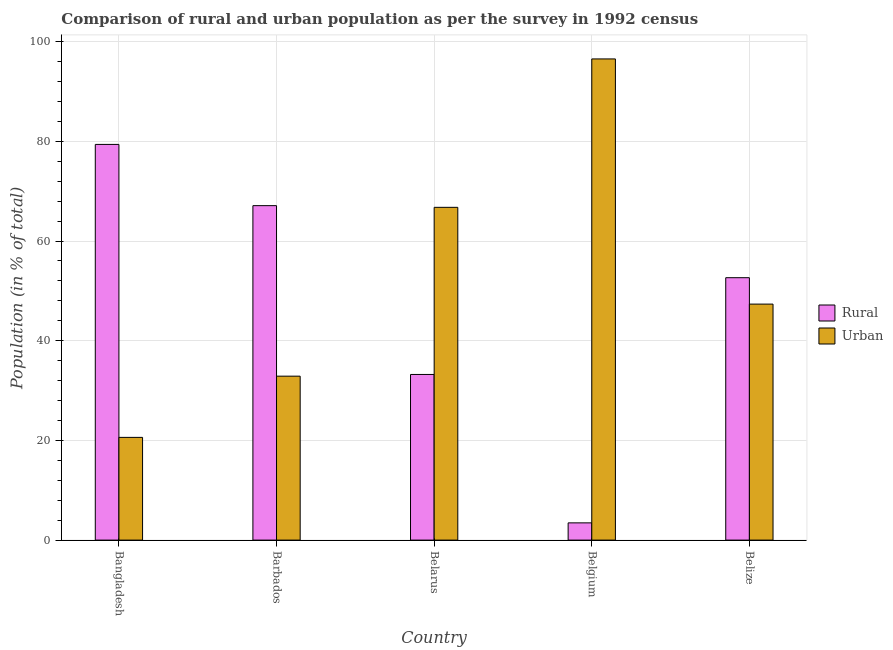How many different coloured bars are there?
Provide a succinct answer. 2. How many groups of bars are there?
Provide a short and direct response. 5. Are the number of bars per tick equal to the number of legend labels?
Give a very brief answer. Yes. Are the number of bars on each tick of the X-axis equal?
Give a very brief answer. Yes. What is the label of the 3rd group of bars from the left?
Keep it short and to the point. Belarus. What is the urban population in Belarus?
Offer a terse response. 66.77. Across all countries, what is the maximum urban population?
Provide a short and direct response. 96.54. Across all countries, what is the minimum rural population?
Provide a succinct answer. 3.46. In which country was the urban population maximum?
Keep it short and to the point. Belgium. What is the total urban population in the graph?
Make the answer very short. 264.16. What is the difference between the rural population in Barbados and that in Belarus?
Offer a terse response. 33.87. What is the difference between the rural population in Bangladesh and the urban population in Belarus?
Provide a succinct answer. 12.62. What is the average rural population per country?
Provide a short and direct response. 47.17. What is the difference between the rural population and urban population in Belgium?
Your response must be concise. -93.08. In how many countries, is the rural population greater than 88 %?
Your answer should be compact. 0. What is the ratio of the urban population in Barbados to that in Belgium?
Your answer should be compact. 0.34. Is the urban population in Bangladesh less than that in Barbados?
Ensure brevity in your answer.  Yes. What is the difference between the highest and the second highest rural population?
Ensure brevity in your answer.  12.28. What is the difference between the highest and the lowest rural population?
Keep it short and to the point. 75.93. Is the sum of the urban population in Bangladesh and Belize greater than the maximum rural population across all countries?
Provide a succinct answer. No. What does the 2nd bar from the left in Belgium represents?
Provide a short and direct response. Urban. What does the 1st bar from the right in Belgium represents?
Your response must be concise. Urban. What is the difference between two consecutive major ticks on the Y-axis?
Your answer should be compact. 20. Are the values on the major ticks of Y-axis written in scientific E-notation?
Your answer should be very brief. No. Does the graph contain any zero values?
Ensure brevity in your answer.  No. Where does the legend appear in the graph?
Make the answer very short. Center right. What is the title of the graph?
Give a very brief answer. Comparison of rural and urban population as per the survey in 1992 census. What is the label or title of the X-axis?
Ensure brevity in your answer.  Country. What is the label or title of the Y-axis?
Keep it short and to the point. Population (in % of total). What is the Population (in % of total) in Rural in Bangladesh?
Your response must be concise. 79.39. What is the Population (in % of total) of Urban in Bangladesh?
Your answer should be very brief. 20.61. What is the Population (in % of total) of Rural in Barbados?
Ensure brevity in your answer.  67.11. What is the Population (in % of total) in Urban in Barbados?
Your response must be concise. 32.89. What is the Population (in % of total) of Rural in Belarus?
Provide a short and direct response. 33.23. What is the Population (in % of total) in Urban in Belarus?
Give a very brief answer. 66.77. What is the Population (in % of total) in Rural in Belgium?
Give a very brief answer. 3.46. What is the Population (in % of total) in Urban in Belgium?
Your answer should be very brief. 96.54. What is the Population (in % of total) of Rural in Belize?
Your response must be concise. 52.65. What is the Population (in % of total) in Urban in Belize?
Offer a very short reply. 47.35. Across all countries, what is the maximum Population (in % of total) of Rural?
Make the answer very short. 79.39. Across all countries, what is the maximum Population (in % of total) of Urban?
Ensure brevity in your answer.  96.54. Across all countries, what is the minimum Population (in % of total) of Rural?
Your answer should be very brief. 3.46. Across all countries, what is the minimum Population (in % of total) in Urban?
Provide a succinct answer. 20.61. What is the total Population (in % of total) in Rural in the graph?
Give a very brief answer. 235.84. What is the total Population (in % of total) of Urban in the graph?
Offer a terse response. 264.16. What is the difference between the Population (in % of total) in Rural in Bangladesh and that in Barbados?
Make the answer very short. 12.28. What is the difference between the Population (in % of total) in Urban in Bangladesh and that in Barbados?
Offer a terse response. -12.28. What is the difference between the Population (in % of total) in Rural in Bangladesh and that in Belarus?
Provide a succinct answer. 46.16. What is the difference between the Population (in % of total) in Urban in Bangladesh and that in Belarus?
Keep it short and to the point. -46.16. What is the difference between the Population (in % of total) in Rural in Bangladesh and that in Belgium?
Your answer should be compact. 75.93. What is the difference between the Population (in % of total) in Urban in Bangladesh and that in Belgium?
Your response must be concise. -75.93. What is the difference between the Population (in % of total) of Rural in Bangladesh and that in Belize?
Offer a terse response. 26.74. What is the difference between the Population (in % of total) of Urban in Bangladesh and that in Belize?
Keep it short and to the point. -26.74. What is the difference between the Population (in % of total) of Rural in Barbados and that in Belarus?
Your answer should be very brief. 33.87. What is the difference between the Population (in % of total) of Urban in Barbados and that in Belarus?
Provide a short and direct response. -33.87. What is the difference between the Population (in % of total) in Rural in Barbados and that in Belgium?
Ensure brevity in your answer.  63.65. What is the difference between the Population (in % of total) in Urban in Barbados and that in Belgium?
Your answer should be compact. -63.65. What is the difference between the Population (in % of total) in Rural in Barbados and that in Belize?
Your response must be concise. 14.46. What is the difference between the Population (in % of total) of Urban in Barbados and that in Belize?
Offer a terse response. -14.46. What is the difference between the Population (in % of total) of Rural in Belarus and that in Belgium?
Provide a succinct answer. 29.78. What is the difference between the Population (in % of total) of Urban in Belarus and that in Belgium?
Provide a succinct answer. -29.78. What is the difference between the Population (in % of total) in Rural in Belarus and that in Belize?
Provide a succinct answer. -19.41. What is the difference between the Population (in % of total) of Urban in Belarus and that in Belize?
Offer a very short reply. 19.41. What is the difference between the Population (in % of total) in Rural in Belgium and that in Belize?
Offer a very short reply. -49.19. What is the difference between the Population (in % of total) in Urban in Belgium and that in Belize?
Offer a terse response. 49.19. What is the difference between the Population (in % of total) in Rural in Bangladesh and the Population (in % of total) in Urban in Barbados?
Your answer should be very brief. 46.5. What is the difference between the Population (in % of total) in Rural in Bangladesh and the Population (in % of total) in Urban in Belarus?
Make the answer very short. 12.62. What is the difference between the Population (in % of total) in Rural in Bangladesh and the Population (in % of total) in Urban in Belgium?
Make the answer very short. -17.15. What is the difference between the Population (in % of total) in Rural in Bangladesh and the Population (in % of total) in Urban in Belize?
Keep it short and to the point. 32.04. What is the difference between the Population (in % of total) in Rural in Barbados and the Population (in % of total) in Urban in Belarus?
Offer a very short reply. 0.34. What is the difference between the Population (in % of total) of Rural in Barbados and the Population (in % of total) of Urban in Belgium?
Offer a terse response. -29.44. What is the difference between the Population (in % of total) of Rural in Barbados and the Population (in % of total) of Urban in Belize?
Offer a terse response. 19.75. What is the difference between the Population (in % of total) in Rural in Belarus and the Population (in % of total) in Urban in Belgium?
Your response must be concise. -63.31. What is the difference between the Population (in % of total) in Rural in Belarus and the Population (in % of total) in Urban in Belize?
Provide a short and direct response. -14.12. What is the difference between the Population (in % of total) of Rural in Belgium and the Population (in % of total) of Urban in Belize?
Keep it short and to the point. -43.89. What is the average Population (in % of total) of Rural per country?
Offer a terse response. 47.17. What is the average Population (in % of total) in Urban per country?
Provide a succinct answer. 52.83. What is the difference between the Population (in % of total) in Rural and Population (in % of total) in Urban in Bangladesh?
Provide a short and direct response. 58.78. What is the difference between the Population (in % of total) of Rural and Population (in % of total) of Urban in Barbados?
Keep it short and to the point. 34.21. What is the difference between the Population (in % of total) in Rural and Population (in % of total) in Urban in Belarus?
Make the answer very short. -33.53. What is the difference between the Population (in % of total) of Rural and Population (in % of total) of Urban in Belgium?
Offer a terse response. -93.08. What is the difference between the Population (in % of total) of Rural and Population (in % of total) of Urban in Belize?
Your answer should be compact. 5.3. What is the ratio of the Population (in % of total) in Rural in Bangladesh to that in Barbados?
Your answer should be very brief. 1.18. What is the ratio of the Population (in % of total) of Urban in Bangladesh to that in Barbados?
Provide a short and direct response. 0.63. What is the ratio of the Population (in % of total) of Rural in Bangladesh to that in Belarus?
Provide a short and direct response. 2.39. What is the ratio of the Population (in % of total) in Urban in Bangladesh to that in Belarus?
Make the answer very short. 0.31. What is the ratio of the Population (in % of total) of Rural in Bangladesh to that in Belgium?
Offer a terse response. 22.96. What is the ratio of the Population (in % of total) in Urban in Bangladesh to that in Belgium?
Provide a short and direct response. 0.21. What is the ratio of the Population (in % of total) of Rural in Bangladesh to that in Belize?
Provide a short and direct response. 1.51. What is the ratio of the Population (in % of total) in Urban in Bangladesh to that in Belize?
Keep it short and to the point. 0.44. What is the ratio of the Population (in % of total) in Rural in Barbados to that in Belarus?
Offer a very short reply. 2.02. What is the ratio of the Population (in % of total) of Urban in Barbados to that in Belarus?
Provide a succinct answer. 0.49. What is the ratio of the Population (in % of total) in Rural in Barbados to that in Belgium?
Provide a short and direct response. 19.41. What is the ratio of the Population (in % of total) of Urban in Barbados to that in Belgium?
Your answer should be very brief. 0.34. What is the ratio of the Population (in % of total) in Rural in Barbados to that in Belize?
Your answer should be very brief. 1.27. What is the ratio of the Population (in % of total) of Urban in Barbados to that in Belize?
Keep it short and to the point. 0.69. What is the ratio of the Population (in % of total) of Rural in Belarus to that in Belgium?
Provide a succinct answer. 9.61. What is the ratio of the Population (in % of total) in Urban in Belarus to that in Belgium?
Give a very brief answer. 0.69. What is the ratio of the Population (in % of total) of Rural in Belarus to that in Belize?
Ensure brevity in your answer.  0.63. What is the ratio of the Population (in % of total) of Urban in Belarus to that in Belize?
Offer a very short reply. 1.41. What is the ratio of the Population (in % of total) of Rural in Belgium to that in Belize?
Provide a succinct answer. 0.07. What is the ratio of the Population (in % of total) in Urban in Belgium to that in Belize?
Offer a very short reply. 2.04. What is the difference between the highest and the second highest Population (in % of total) in Rural?
Offer a terse response. 12.28. What is the difference between the highest and the second highest Population (in % of total) in Urban?
Give a very brief answer. 29.78. What is the difference between the highest and the lowest Population (in % of total) in Rural?
Make the answer very short. 75.93. What is the difference between the highest and the lowest Population (in % of total) of Urban?
Your answer should be compact. 75.93. 